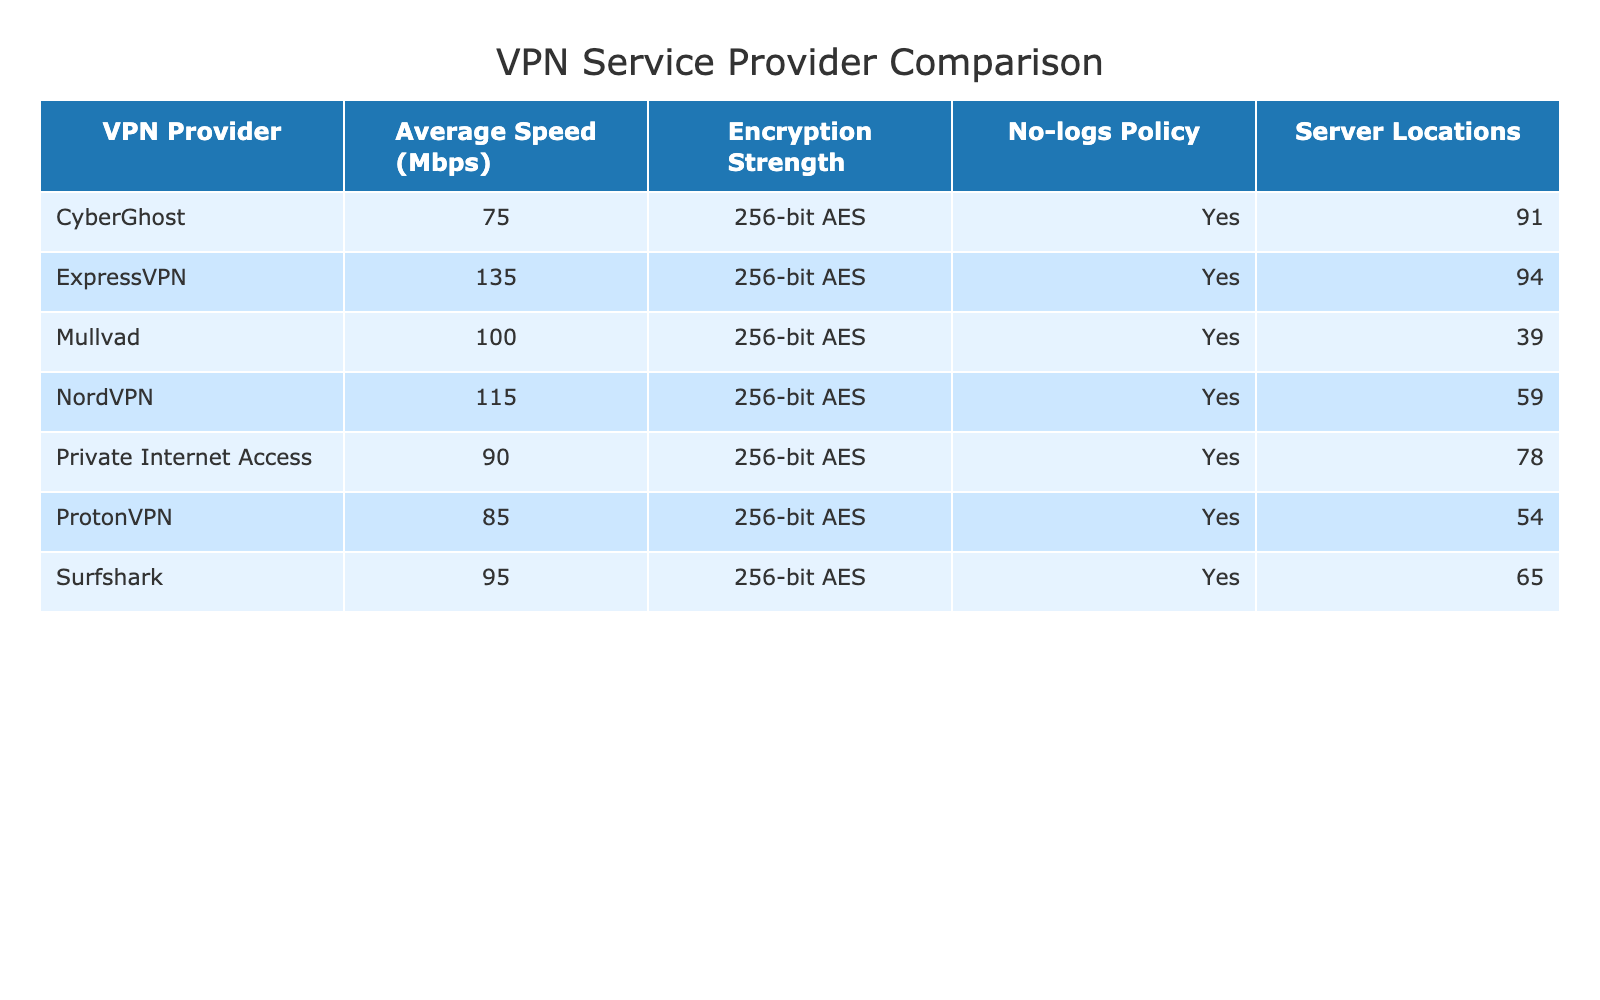What is the encryption strength used by all VPN providers listed? By inspecting the table, all VPN providers have 256-bit AES encryption strength mentioned.
Answer: 256-bit AES Which VPN provider has the highest average speed? The average speeds for each provider are listed: NordVPN (115 Mbps), ExpressVPN (135 Mbps), Surfshark (95 Mbps), ProtonVPN (85 Mbps), CyberGhost (75 Mbps), Mullvad (100 Mbps), and Private Internet Access (90 Mbps). Comparing these values, ExpressVPN has the highest speed at 135 Mbps.
Answer: ExpressVPN Which provider has the lowest number of server locations? The number of server locations for each provider is: NordVPN (59), ExpressVPN (94), Surfshark (65), ProtonVPN (54), CyberGhost (91), Mullvad (39), and Private Internet Access (78). The lowest is Mullvad with 39 server locations.
Answer: Mullvad Do all VPN providers have a no-logs policy? Checking the table, it shows a 'Yes' for the no-logs policy for every VPN provider listed.
Answer: Yes What is the average speed of NordVPN and Mullvad combined? The average speeds are 115 Mbps for NordVPN and 100 Mbps for Mullvad. To find the combined average: (115 + 100) / 2 = 107.5 Mbps.
Answer: 107.5 Mbps Which VPN provider has the most server locations and by how many compared to the provider with the least? The provider with the most server locations is ExpressVPN (94), while Mullvad has the least (39). The difference is 94 - 39 = 55.
Answer: 55 Has ProtonVPN the highest or lowest server locations among all providers? Referring to the numbers, ProtonVPN has 54 server locations, which is neither the highest nor the lowest; it is among the lower half. Its count is more than Mullvad but less than others.
Answer: Lowest If you were to rank the VPN providers based on average speed from highest to lowest, which one would rank fourth? The average speeds from highest to lowest are: ExpressVPN (135), NordVPN (115), Mullvad (100), Private Internet Access (90), Surfshark (95), ProtonVPN (85), CyberGhost (75). The fourth ranking is Private Internet Access (90).
Answer: Private Internet Access What percentage of the VPN providers listed have a no-logs policy? All 7 VPN providers have a no-logs policy, which means the percentage is (7/7) * 100% = 100%.
Answer: 100% Which VPN provider has more server locations, Surfshark or ProtonVPN, and by how many? Surfshark has 65 server locations while ProtonVPN has 54. The difference is 65 - 54 = 11.
Answer: 11 